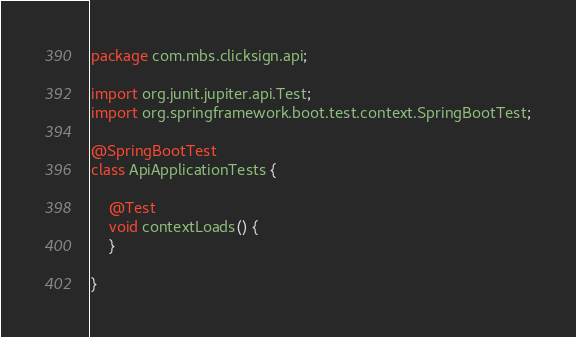<code> <loc_0><loc_0><loc_500><loc_500><_Java_>package com.mbs.clicksign.api;

import org.junit.jupiter.api.Test;
import org.springframework.boot.test.context.SpringBootTest;

@SpringBootTest
class ApiApplicationTests {

    @Test
    void contextLoads() {
    }

}
</code> 